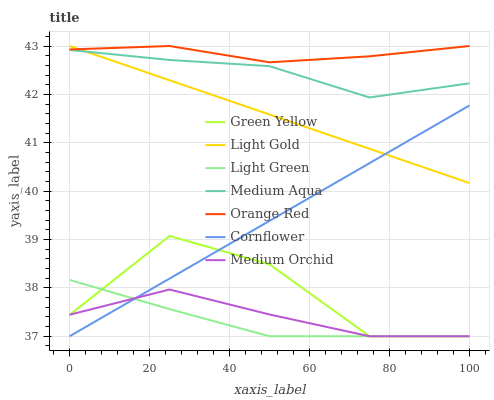Does Light Green have the minimum area under the curve?
Answer yes or no. Yes. Does Orange Red have the maximum area under the curve?
Answer yes or no. Yes. Does Medium Orchid have the minimum area under the curve?
Answer yes or no. No. Does Medium Orchid have the maximum area under the curve?
Answer yes or no. No. Is Cornflower the smoothest?
Answer yes or no. Yes. Is Green Yellow the roughest?
Answer yes or no. Yes. Is Medium Orchid the smoothest?
Answer yes or no. No. Is Medium Orchid the roughest?
Answer yes or no. No. Does Cornflower have the lowest value?
Answer yes or no. Yes. Does Medium Aqua have the lowest value?
Answer yes or no. No. Does Orange Red have the highest value?
Answer yes or no. Yes. Does Medium Aqua have the highest value?
Answer yes or no. No. Is Medium Orchid less than Medium Aqua?
Answer yes or no. Yes. Is Light Gold greater than Medium Orchid?
Answer yes or no. Yes. Does Light Green intersect Green Yellow?
Answer yes or no. Yes. Is Light Green less than Green Yellow?
Answer yes or no. No. Is Light Green greater than Green Yellow?
Answer yes or no. No. Does Medium Orchid intersect Medium Aqua?
Answer yes or no. No. 